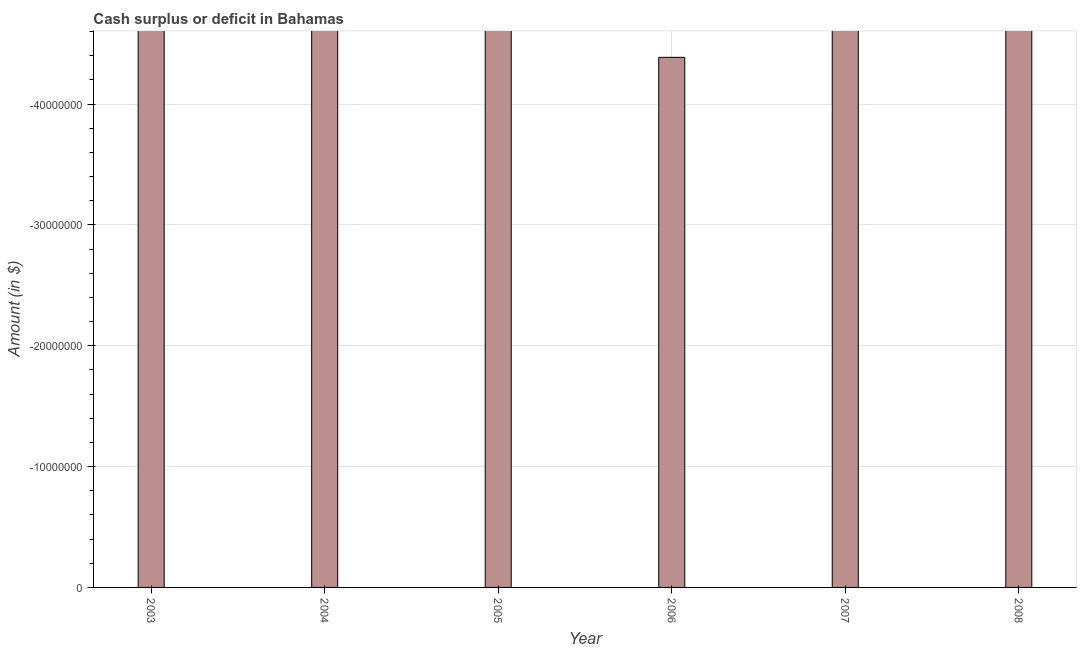Does the graph contain grids?
Your answer should be very brief. Yes. What is the title of the graph?
Your answer should be compact. Cash surplus or deficit in Bahamas. What is the label or title of the Y-axis?
Provide a short and direct response. Amount (in $). What is the cash surplus or deficit in 2008?
Make the answer very short. 0. What is the average cash surplus or deficit per year?
Keep it short and to the point. 0. What is the median cash surplus or deficit?
Provide a short and direct response. 0. In how many years, is the cash surplus or deficit greater than -8000000 $?
Provide a short and direct response. 0. In how many years, is the cash surplus or deficit greater than the average cash surplus or deficit taken over all years?
Offer a very short reply. 0. How many bars are there?
Offer a terse response. 0. Are all the bars in the graph horizontal?
Offer a very short reply. No. What is the difference between two consecutive major ticks on the Y-axis?
Keep it short and to the point. 1.00e+07. What is the Amount (in $) in 2004?
Provide a succinct answer. 0. What is the Amount (in $) in 2006?
Keep it short and to the point. 0. 